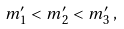<formula> <loc_0><loc_0><loc_500><loc_500>m ^ { \prime } _ { 1 } < m ^ { \prime } _ { 2 } < m ^ { \prime } _ { 3 } \, ,</formula> 